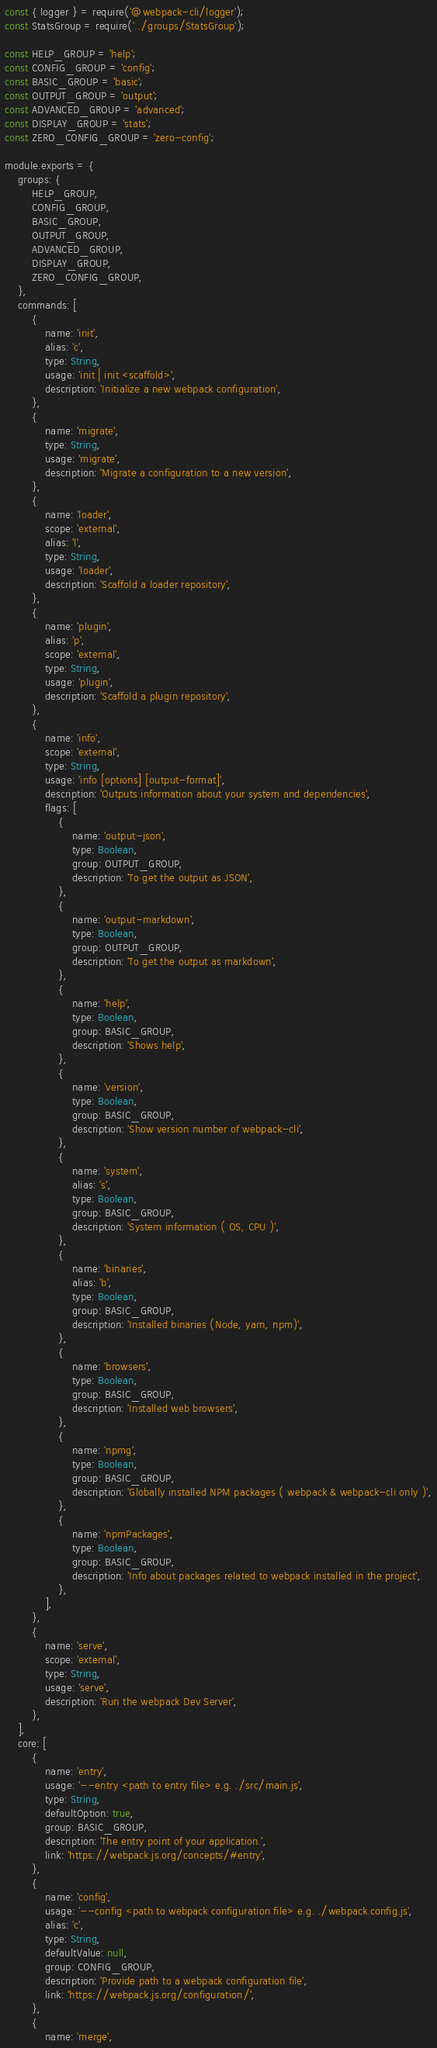Convert code to text. <code><loc_0><loc_0><loc_500><loc_500><_JavaScript_>const { logger } = require('@webpack-cli/logger');
const StatsGroup = require('../groups/StatsGroup');

const HELP_GROUP = 'help';
const CONFIG_GROUP = 'config';
const BASIC_GROUP = 'basic';
const OUTPUT_GROUP = 'output';
const ADVANCED_GROUP = 'advanced';
const DISPLAY_GROUP = 'stats';
const ZERO_CONFIG_GROUP = 'zero-config';

module.exports = {
    groups: {
        HELP_GROUP,
        CONFIG_GROUP,
        BASIC_GROUP,
        OUTPUT_GROUP,
        ADVANCED_GROUP,
        DISPLAY_GROUP,
        ZERO_CONFIG_GROUP,
    },
    commands: [
        {
            name: 'init',
            alias: 'c',
            type: String,
            usage: 'init | init <scaffold>',
            description: 'Initialize a new webpack configuration',
        },
        {
            name: 'migrate',
            type: String,
            usage: 'migrate',
            description: 'Migrate a configuration to a new version',
        },
        {
            name: 'loader',
            scope: 'external',
            alias: 'l',
            type: String,
            usage: 'loader',
            description: 'Scaffold a loader repository',
        },
        {
            name: 'plugin',
            alias: 'p',
            scope: 'external',
            type: String,
            usage: 'plugin',
            description: 'Scaffold a plugin repository',
        },
        {
            name: 'info',
            scope: 'external',
            type: String,
            usage: 'info [options] [output-format]',
            description: 'Outputs information about your system and dependencies',
            flags: [
                {
                    name: 'output-json',
                    type: Boolean,
                    group: OUTPUT_GROUP,
                    description: 'To get the output as JSON',
                },
                {
                    name: 'output-markdown',
                    type: Boolean,
                    group: OUTPUT_GROUP,
                    description: 'To get the output as markdown',
                },
                {
                    name: 'help',
                    type: Boolean,
                    group: BASIC_GROUP,
                    description: 'Shows help',
                },
                {
                    name: 'version',
                    type: Boolean,
                    group: BASIC_GROUP,
                    description: 'Show version number of webpack-cli',
                },
                {
                    name: 'system',
                    alias: 's',
                    type: Boolean,
                    group: BASIC_GROUP,
                    description: 'System information ( OS, CPU )',
                },
                {
                    name: 'binaries',
                    alias: 'b',
                    type: Boolean,
                    group: BASIC_GROUP,
                    description: 'Installed binaries (Node, yarn, npm)',
                },
                {
                    name: 'browsers',
                    type: Boolean,
                    group: BASIC_GROUP,
                    description: 'Installed web browsers',
                },
                {
                    name: 'npmg',
                    type: Boolean,
                    group: BASIC_GROUP,
                    description: 'Globally installed NPM packages ( webpack & webpack-cli only )',
                },
                {
                    name: 'npmPackages',
                    type: Boolean,
                    group: BASIC_GROUP,
                    description: 'Info about packages related to webpack installed in the project',
                },
            ],
        },
        {
            name: 'serve',
            scope: 'external',
            type: String,
            usage: 'serve',
            description: 'Run the webpack Dev Server',
        },
    ],
    core: [
        {
            name: 'entry',
            usage: '--entry <path to entry file> e.g. ./src/main.js',
            type: String,
            defaultOption: true,
            group: BASIC_GROUP,
            description: 'The entry point of your application.',
            link: 'https://webpack.js.org/concepts/#entry',
        },
        {
            name: 'config',
            usage: '--config <path to webpack configuration file> e.g. ./webpack.config.js',
            alias: 'c',
            type: String,
            defaultValue: null,
            group: CONFIG_GROUP,
            description: 'Provide path to a webpack configuration file',
            link: 'https://webpack.js.org/configuration/',
        },
        {
            name: 'merge',</code> 